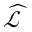Convert formula to latex. <formula><loc_0><loc_0><loc_500><loc_500>\widehat { \mathcal { L } }</formula> 